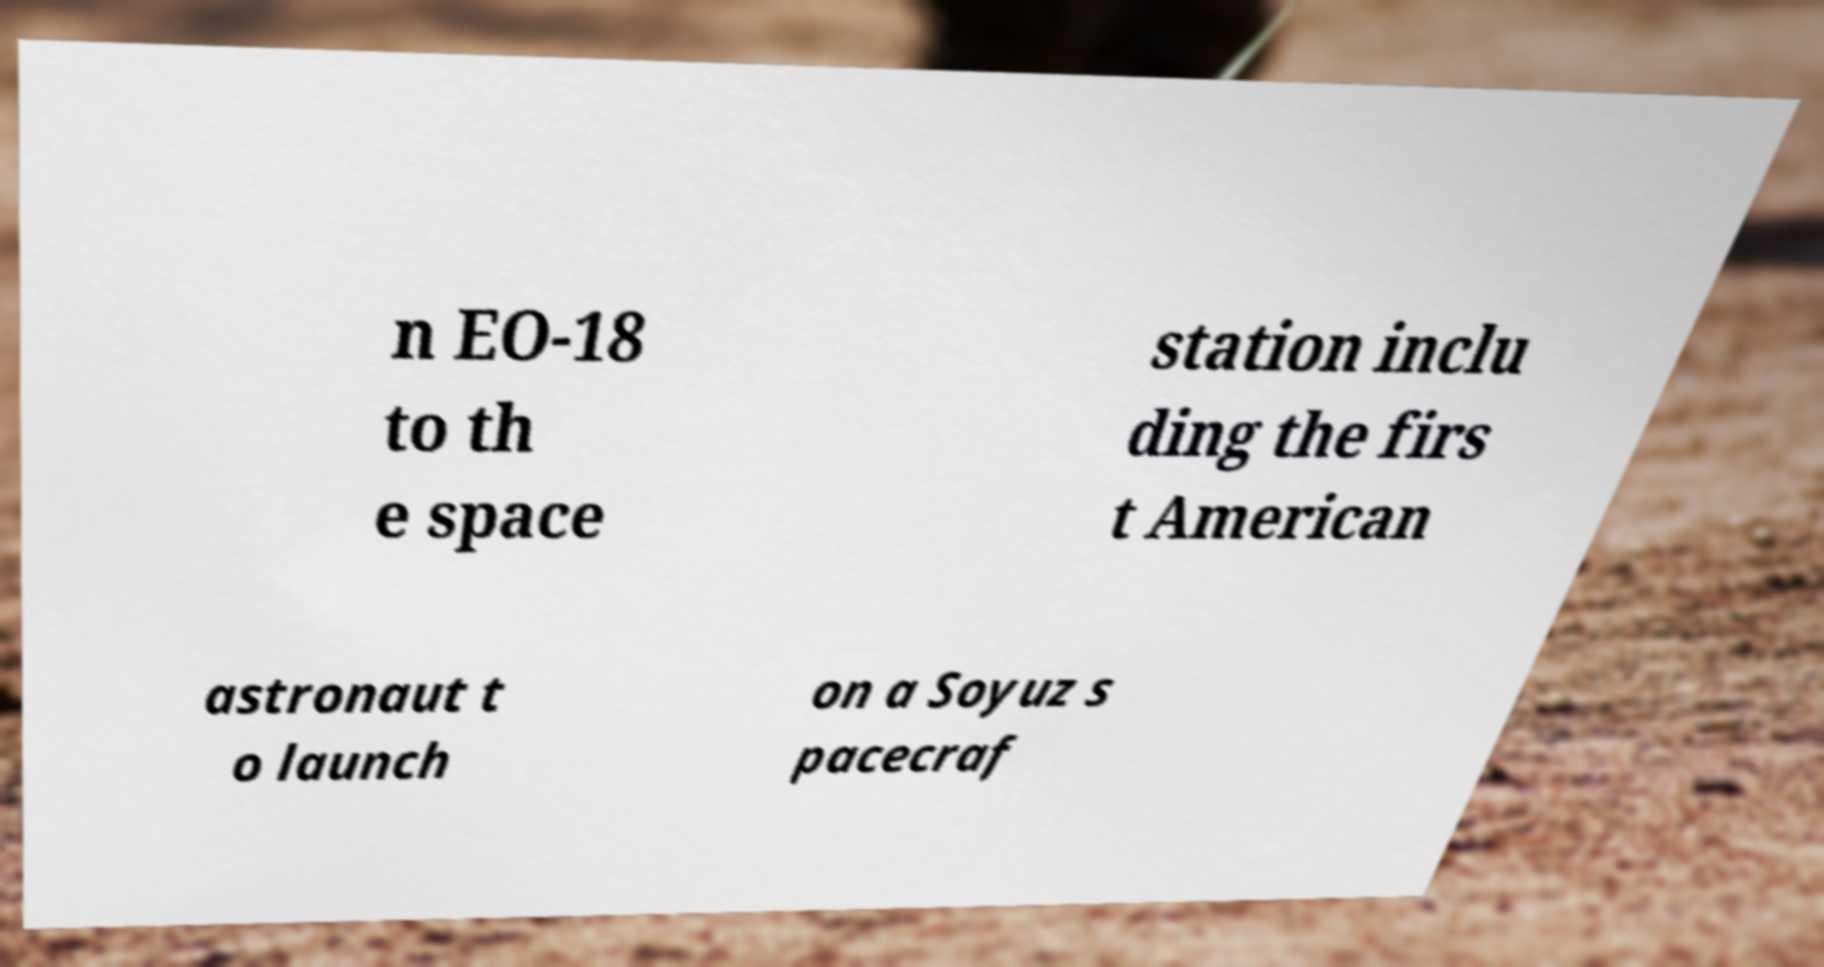Can you read and provide the text displayed in the image?This photo seems to have some interesting text. Can you extract and type it out for me? n EO-18 to th e space station inclu ding the firs t American astronaut t o launch on a Soyuz s pacecraf 